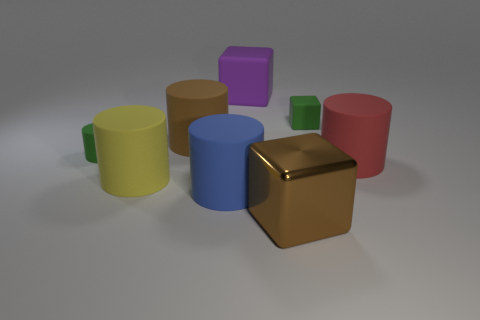How many objects are in the image, and can you describe their shapes? There are nine objects in the image. Starting from the left, there is a yellow cylinder, a large brown cylinder, a red cylinder, a green cube, a small green cylinder, a blue cube, a purple cube, a pink cylinder, and at the front, a reflective gold cube. Which object stands out the most to you and why? The reflective gold cube stands out the most due to its shiny, reflective surface that contrasts with the matte textures of the other objects, as well as its distinctive gold color that catches the eye among the various colors present. 